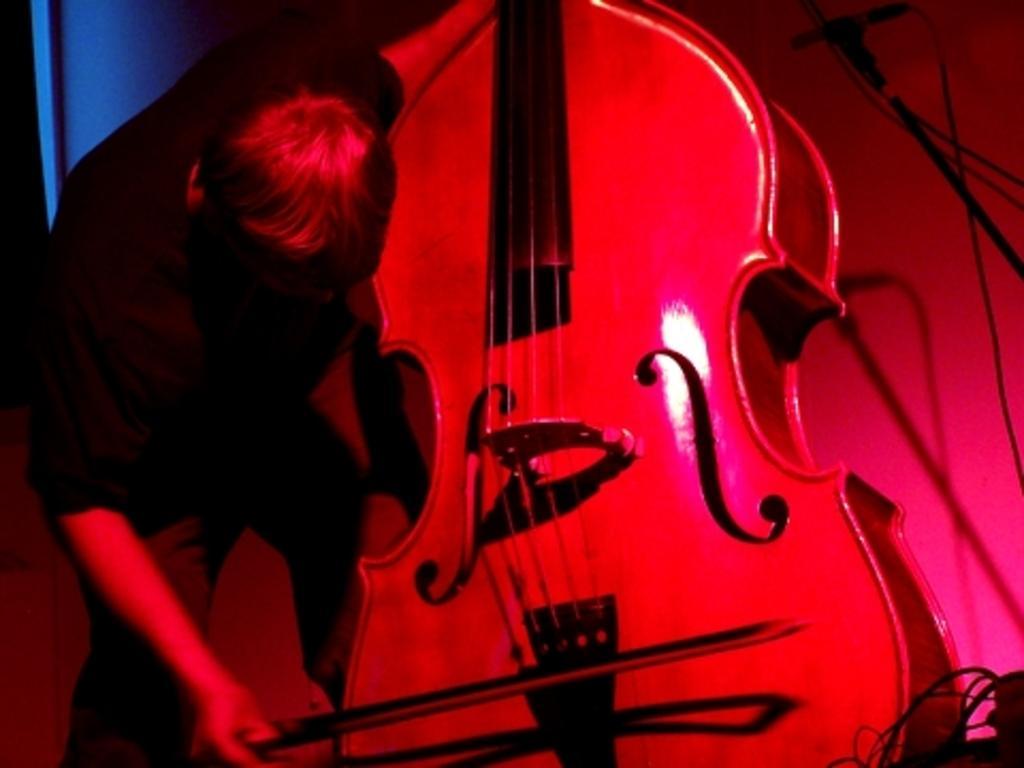Can you describe this image briefly? In this image, we can see a person playing guitar. 